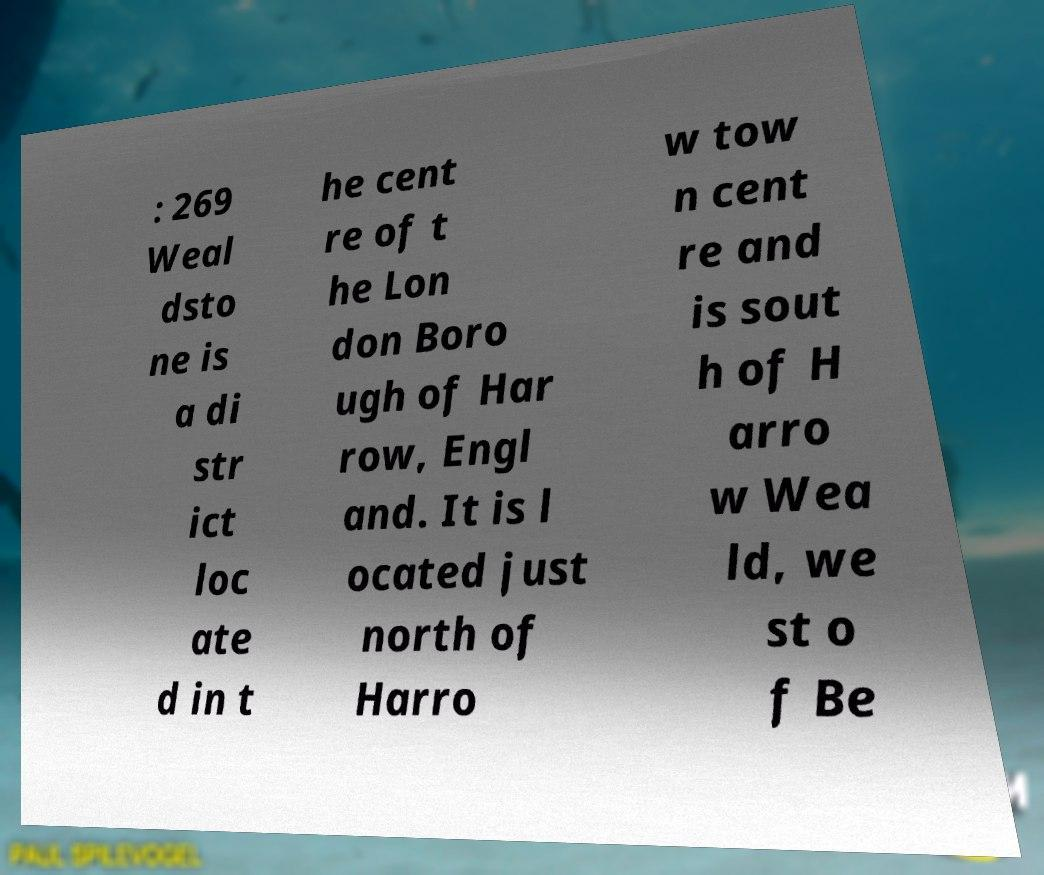Can you accurately transcribe the text from the provided image for me? : 269 Weal dsto ne is a di str ict loc ate d in t he cent re of t he Lon don Boro ugh of Har row, Engl and. It is l ocated just north of Harro w tow n cent re and is sout h of H arro w Wea ld, we st o f Be 